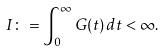Convert formula to latex. <formula><loc_0><loc_0><loc_500><loc_500>I \colon = \int _ { 0 } ^ { \infty } G ( t ) \, d t < \infty .</formula> 